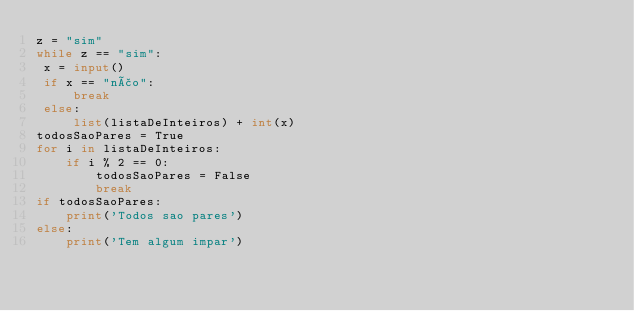<code> <loc_0><loc_0><loc_500><loc_500><_Python_>z = "sim"
while z == "sim":
 x = input()
 if x == "não":
     break
 else:
     list(listaDeInteiros) + int(x)
todosSaoPares = True
for i in listaDeInteiros:
    if i % 2 == 0:
        todosSaoPares = False
        break
if todosSaoPares:
    print('Todos sao pares')
else:
    print('Tem algum impar')</code> 